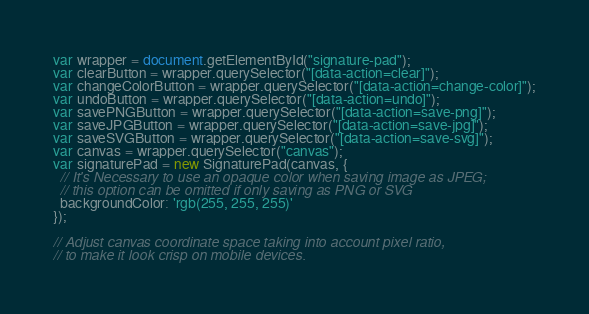<code> <loc_0><loc_0><loc_500><loc_500><_JavaScript_>var wrapper = document.getElementById("signature-pad");
var clearButton = wrapper.querySelector("[data-action=clear]");
var changeColorButton = wrapper.querySelector("[data-action=change-color]");
var undoButton = wrapper.querySelector("[data-action=undo]");
var savePNGButton = wrapper.querySelector("[data-action=save-png]");
var saveJPGButton = wrapper.querySelector("[data-action=save-jpg]");
var saveSVGButton = wrapper.querySelector("[data-action=save-svg]");
var canvas = wrapper.querySelector("canvas");
var signaturePad = new SignaturePad(canvas, {
  // It's Necessary to use an opaque color when saving image as JPEG;
  // this option can be omitted if only saving as PNG or SVG
  backgroundColor: 'rgb(255, 255, 255)'
});

// Adjust canvas coordinate space taking into account pixel ratio,
// to make it look crisp on mobile devices.</code> 